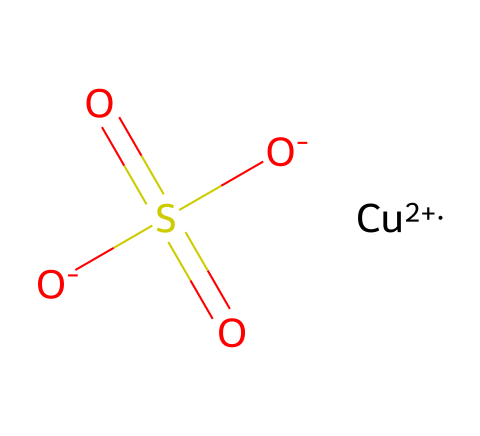What is the chemical name of this compound? The SMILES representation indicates the presence of copper (Cu) and sulfate (SO4). Therefore, the chemical name is copper sulfate.
Answer: copper sulfate How many oxygen atoms are present in this structure? By analyzing the sulfate group in the SMILES, which has four oxygen atoms, and considering the two negatively charged oxygens that are part of the sulfate, we find a total of four oxygen atoms.
Answer: four What is the charge on the copper atom in this compound? The notation [Cu+2] in the SMILES indicates that the copper atom has a charge of +2.
Answer: +2 What is the oxidation state of sulfur in copper sulfate? In the sulfate ion (SO4), sulfur typically exhibits an oxidation state of +6 due to its bonding with four oxygen atoms, each contributing -2.
Answer: +6 What type of bond connects copper to the sulfate group? The linkage between copper and the sulfate ion typically involves ionic bonding due to the transfer of electrons from copper (which has a positive charge) to the negatively charged sulfate group.
Answer: ionic bond Why is copper sulfate used as a fungicide? Copper sulfate disrupts the enzymatic processes in fungi through its toxic effects and is effective against a wide range of fungal pathogens due to its ability to interfere with their cellular structure.
Answer: disrupts enzymatic processes 